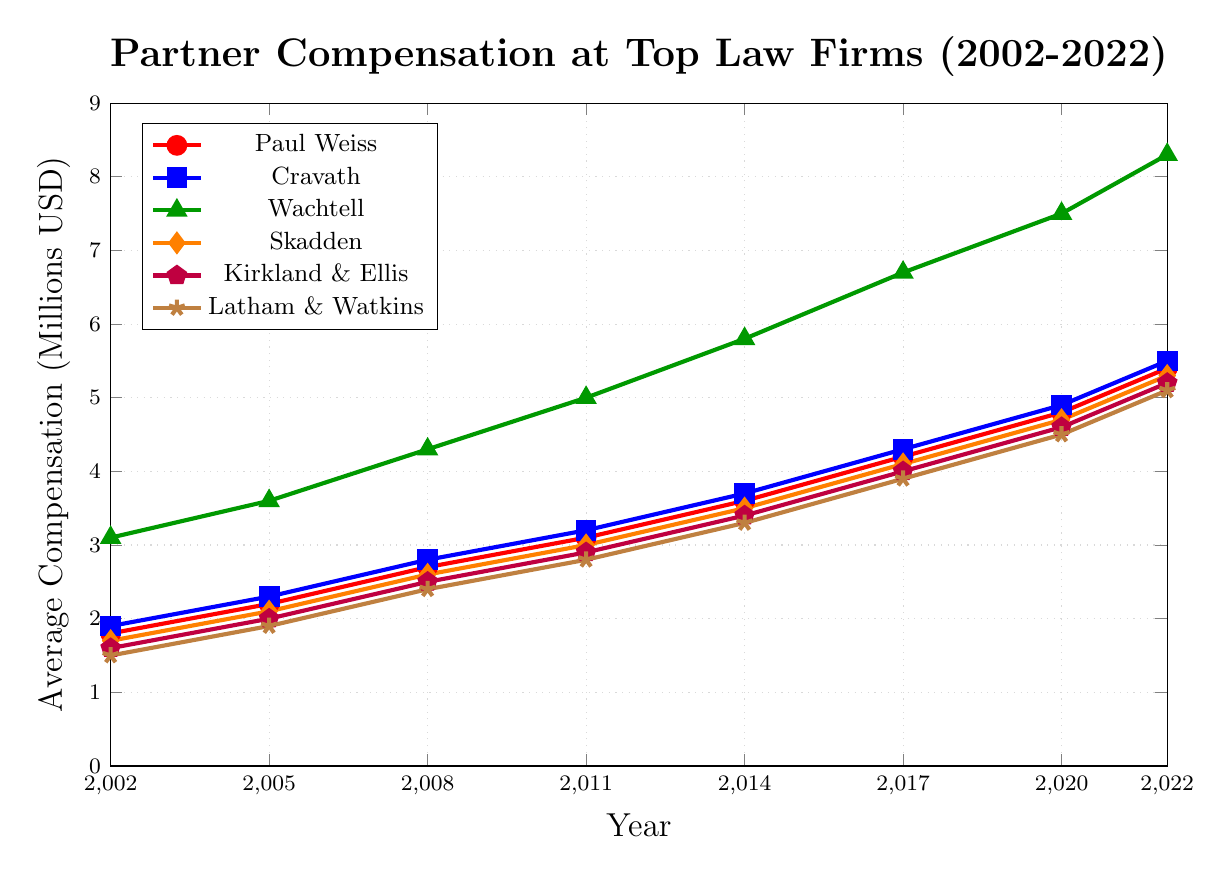What is the average partner compensation for Paul Weiss and Cravath in 2022? To find the average, sum the partner compensations for Paul Weiss and Cravath in 2022 and divide by 2. (5.4 + 5.5) = 10.9, so the average is 10.9 / 2 = 5.45
Answer: 5.45 How did the average compensation at Skadden change from 2005 to 2022? To find the change, subtract the 2005 value from the 2022 value. (5.3 - 2.1) = 3.2
Answer: 3.2 Which firm had the highest compensation in 2008? By looking at the 2008 data points for all firms, Wachtell had the highest compensation at 4.3 million USD
Answer: Wachtell What is the overall trend for Paul Weiss's partner compensation from 2002 to 2022? The data shows a consistent increase in partner compensation for Paul Weiss from 1.8 million USD in 2002 to 5.4 million USD in 2022. Thus, the trend is upward.
Answer: Upward trend Compare the compensation growth between Kirkland & Ellis and Latham & Watkins from 2002 to 2022 For Kirkland & Ellis, the growth is (5.2 - 1.6) = 3.6 million USD. For Latham & Watkins, the growth is (5.1 - 1.5) = 3.6 million USD. Both firms experienced a growth of 3.6 million USD.
Answer: Equal growth What is the difference in partner compensation between Wachtell and Skadden in 2020? Subtract Skadden’s 2020 compensation from Wachtell’s 2020 compensation. (7.5 - 4.7) = 2.8
Answer: 2.8 Which firm has consistently remained in the middle range of partner compensation over the years? By examining the trends for all firms, Skadden appears to consistently have mid-range compensation values compared to the others
Answer: Skadden Increase in partner compensation at Cravath from 2002 to 2011 Subtract the 2002 compensation from the 2011 compensation. (3.2 - 1.9) = 1.3
Answer: 1.3 Who had the lowest partner compensation in 2014? Latham & Watkins had the lowest compensation in 2014 at 3.3 million USD
Answer: Latham & Watkins How much did partner compensation for Wachtell increase from 2002 to 2017? Subtract the 2002 value from the 2017 value. (6.7 - 3.1) = 3.6
Answer: 3.6 